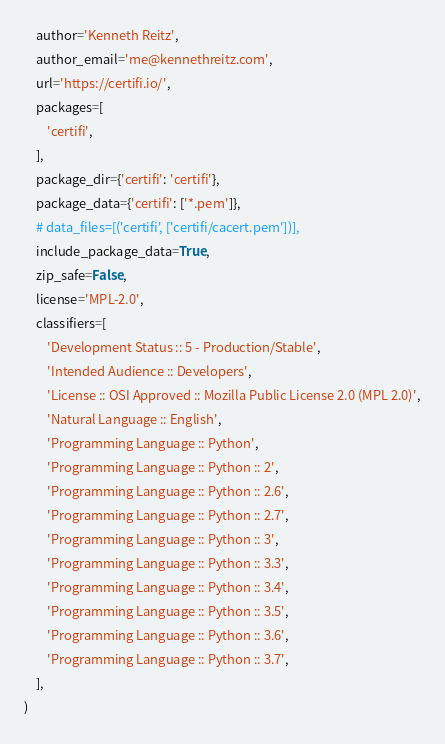<code> <loc_0><loc_0><loc_500><loc_500><_Python_>    author='Kenneth Reitz',
    author_email='me@kennethreitz.com',
    url='https://certifi.io/',
    packages=[
        'certifi',
    ],
    package_dir={'certifi': 'certifi'},
    package_data={'certifi': ['*.pem']},
    # data_files=[('certifi', ['certifi/cacert.pem'])],
    include_package_data=True,
    zip_safe=False,
    license='MPL-2.0',
    classifiers=[
        'Development Status :: 5 - Production/Stable',
        'Intended Audience :: Developers',
        'License :: OSI Approved :: Mozilla Public License 2.0 (MPL 2.0)',
        'Natural Language :: English',
        'Programming Language :: Python',
        'Programming Language :: Python :: 2',
        'Programming Language :: Python :: 2.6',
        'Programming Language :: Python :: 2.7',
        'Programming Language :: Python :: 3',
        'Programming Language :: Python :: 3.3',
        'Programming Language :: Python :: 3.4',
        'Programming Language :: Python :: 3.5',
        'Programming Language :: Python :: 3.6',
        'Programming Language :: Python :: 3.7',
    ],
)
</code> 